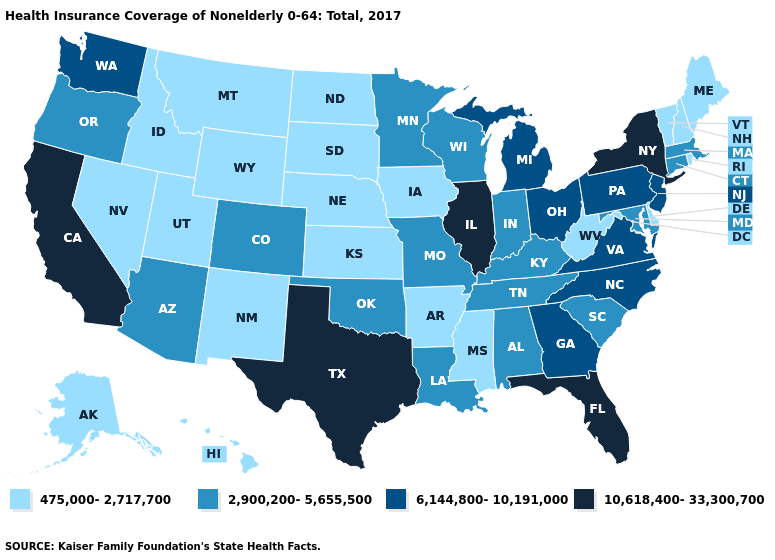Does the first symbol in the legend represent the smallest category?
Short answer required. Yes. What is the value of Mississippi?
Give a very brief answer. 475,000-2,717,700. Name the states that have a value in the range 6,144,800-10,191,000?
Give a very brief answer. Georgia, Michigan, New Jersey, North Carolina, Ohio, Pennsylvania, Virginia, Washington. Name the states that have a value in the range 475,000-2,717,700?
Short answer required. Alaska, Arkansas, Delaware, Hawaii, Idaho, Iowa, Kansas, Maine, Mississippi, Montana, Nebraska, Nevada, New Hampshire, New Mexico, North Dakota, Rhode Island, South Dakota, Utah, Vermont, West Virginia, Wyoming. What is the lowest value in states that border New Mexico?
Quick response, please. 475,000-2,717,700. Which states have the lowest value in the MidWest?
Concise answer only. Iowa, Kansas, Nebraska, North Dakota, South Dakota. Does Washington have a lower value than Illinois?
Answer briefly. Yes. Does New York have the highest value in the Northeast?
Short answer required. Yes. Name the states that have a value in the range 10,618,400-33,300,700?
Concise answer only. California, Florida, Illinois, New York, Texas. What is the value of California?
Short answer required. 10,618,400-33,300,700. Name the states that have a value in the range 10,618,400-33,300,700?
Give a very brief answer. California, Florida, Illinois, New York, Texas. Name the states that have a value in the range 10,618,400-33,300,700?
Quick response, please. California, Florida, Illinois, New York, Texas. Name the states that have a value in the range 10,618,400-33,300,700?
Be succinct. California, Florida, Illinois, New York, Texas. What is the value of West Virginia?
Be succinct. 475,000-2,717,700. 